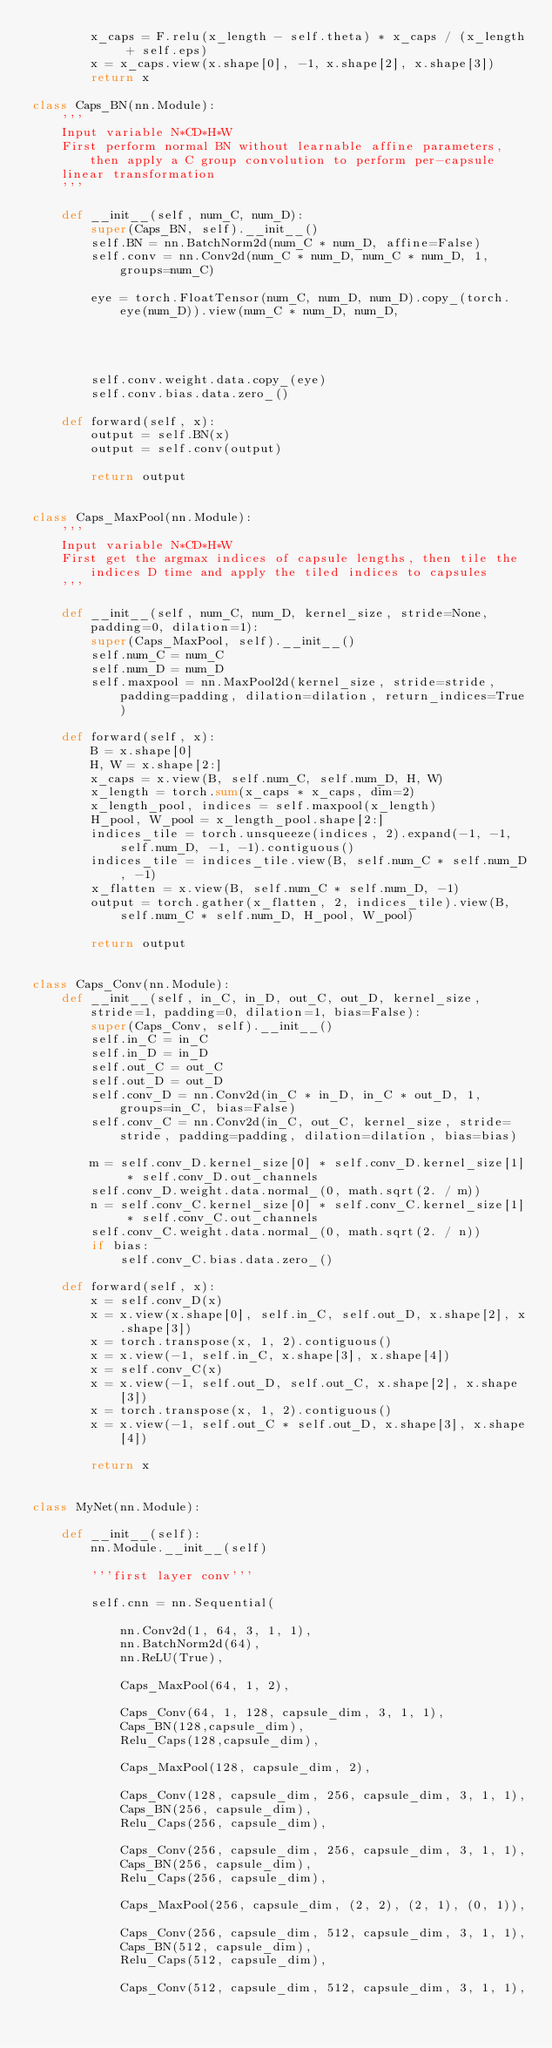Convert code to text. <code><loc_0><loc_0><loc_500><loc_500><_Python_>        x_caps = F.relu(x_length - self.theta) * x_caps / (x_length + self.eps)
        x = x_caps.view(x.shape[0], -1, x.shape[2], x.shape[3])
        return x

class Caps_BN(nn.Module):
    '''
    Input variable N*CD*H*W
    First perform normal BN without learnable affine parameters, then apply a C group convolution to perform per-capsule
    linear transformation
    '''

    def __init__(self, num_C, num_D):
        super(Caps_BN, self).__init__()
        self.BN = nn.BatchNorm2d(num_C * num_D, affine=False)
        self.conv = nn.Conv2d(num_C * num_D, num_C * num_D, 1, groups=num_C)

        eye = torch.FloatTensor(num_C, num_D, num_D).copy_(torch.eye(num_D)).view(num_C * num_D, num_D,
                                                                                                  1, 1)
        self.conv.weight.data.copy_(eye)
        self.conv.bias.data.zero_()

    def forward(self, x):
        output = self.BN(x)
        output = self.conv(output)

        return output


class Caps_MaxPool(nn.Module):
    '''
    Input variable N*CD*H*W
    First get the argmax indices of capsule lengths, then tile the indices D time and apply the tiled indices to capsules
    '''

    def __init__(self, num_C, num_D, kernel_size, stride=None, padding=0, dilation=1):
        super(Caps_MaxPool, self).__init__()
        self.num_C = num_C
        self.num_D = num_D
        self.maxpool = nn.MaxPool2d(kernel_size, stride=stride, padding=padding, dilation=dilation, return_indices=True)

    def forward(self, x):
        B = x.shape[0]
        H, W = x.shape[2:]
        x_caps = x.view(B, self.num_C, self.num_D, H, W)
        x_length = torch.sum(x_caps * x_caps, dim=2)
        x_length_pool, indices = self.maxpool(x_length)
        H_pool, W_pool = x_length_pool.shape[2:]
        indices_tile = torch.unsqueeze(indices, 2).expand(-1, -1, self.num_D, -1, -1).contiguous()
        indices_tile = indices_tile.view(B, self.num_C * self.num_D, -1)
        x_flatten = x.view(B, self.num_C * self.num_D, -1)
        output = torch.gather(x_flatten, 2, indices_tile).view(B, self.num_C * self.num_D, H_pool, W_pool)

        return output


class Caps_Conv(nn.Module):
    def __init__(self, in_C, in_D, out_C, out_D, kernel_size, stride=1, padding=0, dilation=1, bias=False):
        super(Caps_Conv, self).__init__()
        self.in_C = in_C
        self.in_D = in_D
        self.out_C = out_C
        self.out_D = out_D
        self.conv_D = nn.Conv2d(in_C * in_D, in_C * out_D, 1, groups=in_C, bias=False)
        self.conv_C = nn.Conv2d(in_C, out_C, kernel_size, stride=stride, padding=padding, dilation=dilation, bias=bias)

        m = self.conv_D.kernel_size[0] * self.conv_D.kernel_size[1] * self.conv_D.out_channels
        self.conv_D.weight.data.normal_(0, math.sqrt(2. / m))
        n = self.conv_C.kernel_size[0] * self.conv_C.kernel_size[1] * self.conv_C.out_channels
        self.conv_C.weight.data.normal_(0, math.sqrt(2. / n))
        if bias:
            self.conv_C.bias.data.zero_()

    def forward(self, x):
        x = self.conv_D(x)
        x = x.view(x.shape[0], self.in_C, self.out_D, x.shape[2], x.shape[3])
        x = torch.transpose(x, 1, 2).contiguous()
        x = x.view(-1, self.in_C, x.shape[3], x.shape[4])
        x = self.conv_C(x)
        x = x.view(-1, self.out_D, self.out_C, x.shape[2], x.shape[3])
        x = torch.transpose(x, 1, 2).contiguous()
        x = x.view(-1, self.out_C * self.out_D, x.shape[3], x.shape[4])

        return x


class MyNet(nn.Module):

    def __init__(self):
        nn.Module.__init__(self)

        '''first layer conv'''

        self.cnn = nn.Sequential(

            nn.Conv2d(1, 64, 3, 1, 1),
            nn.BatchNorm2d(64),
            nn.ReLU(True),

            Caps_MaxPool(64, 1, 2),

            Caps_Conv(64, 1, 128, capsule_dim, 3, 1, 1),
            Caps_BN(128,capsule_dim),
            Relu_Caps(128,capsule_dim),

            Caps_MaxPool(128, capsule_dim, 2),

            Caps_Conv(128, capsule_dim, 256, capsule_dim, 3, 1, 1),
            Caps_BN(256, capsule_dim),
            Relu_Caps(256, capsule_dim),

            Caps_Conv(256, capsule_dim, 256, capsule_dim, 3, 1, 1),
            Caps_BN(256, capsule_dim),
            Relu_Caps(256, capsule_dim),

            Caps_MaxPool(256, capsule_dim, (2, 2), (2, 1), (0, 1)),

            Caps_Conv(256, capsule_dim, 512, capsule_dim, 3, 1, 1),
            Caps_BN(512, capsule_dim),
            Relu_Caps(512, capsule_dim),

            Caps_Conv(512, capsule_dim, 512, capsule_dim, 3, 1, 1),</code> 